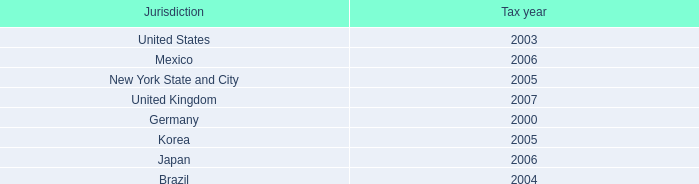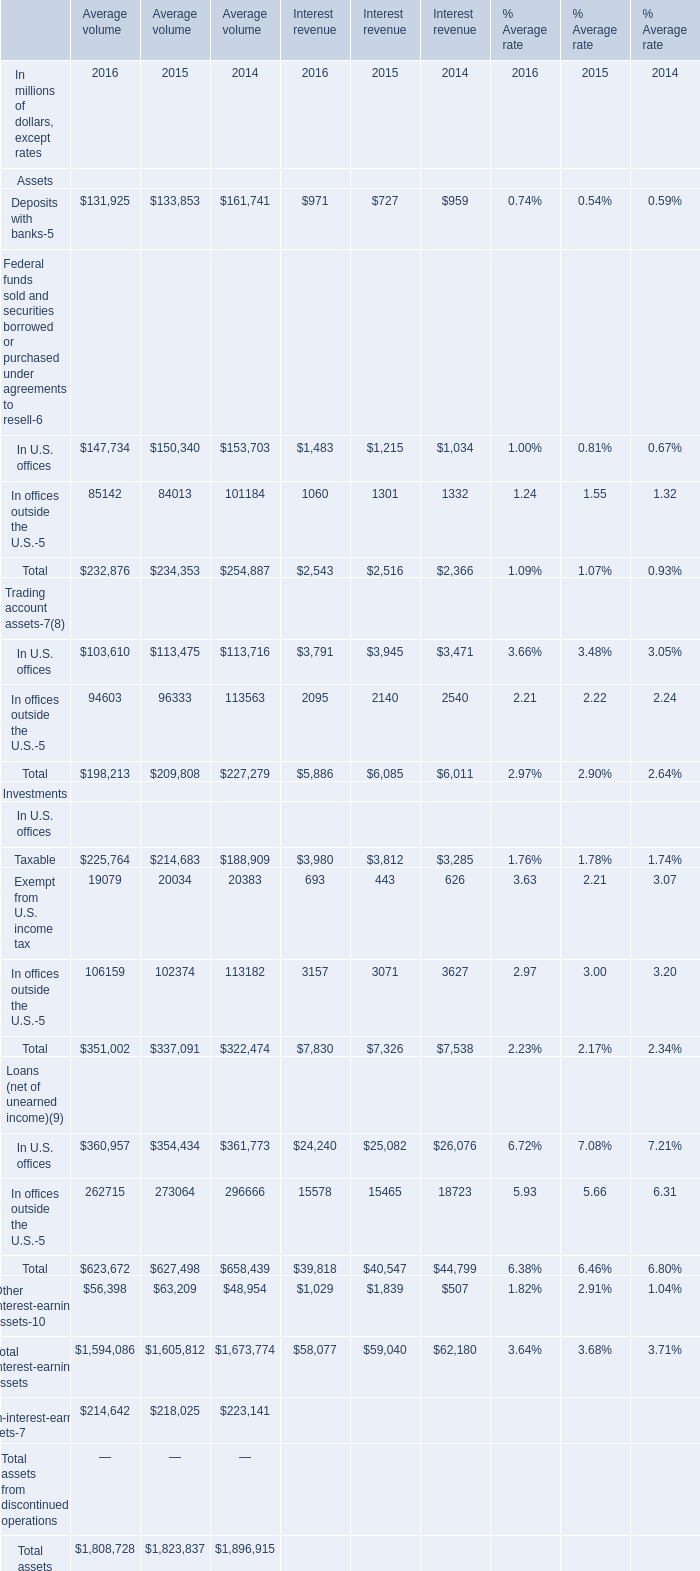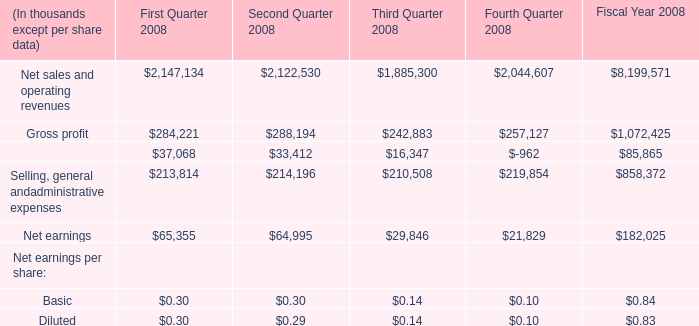at december 31 , 2008 what was the percent of the gross interest associated to the gross uncertain tax position expected to be resolved to 
Computations: (70 / 350)
Answer: 0.2. 